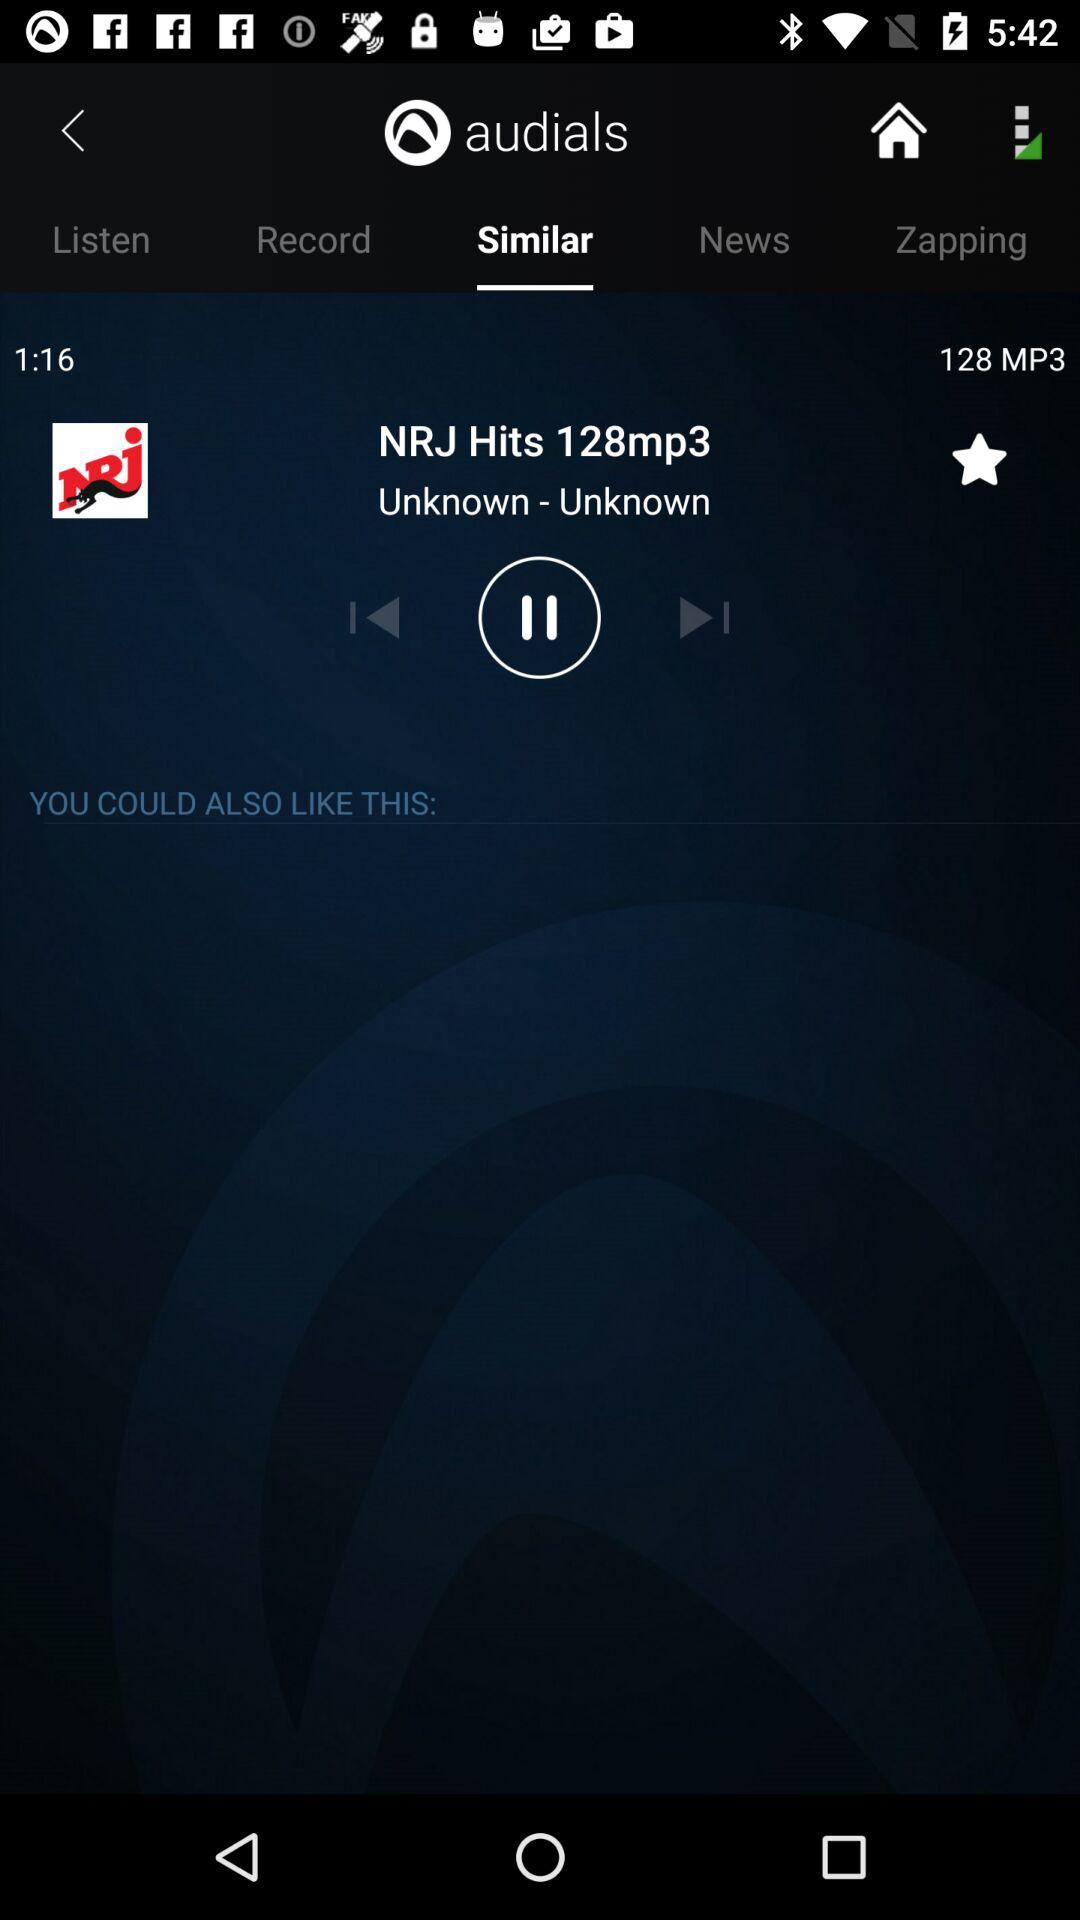What is the time duration? The time duration is 1 minute 16 seconds. 